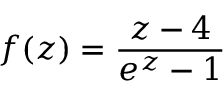Convert formula to latex. <formula><loc_0><loc_0><loc_500><loc_500>f ( z ) = { \frac { z - 4 } { e ^ { z } - 1 } }</formula> 